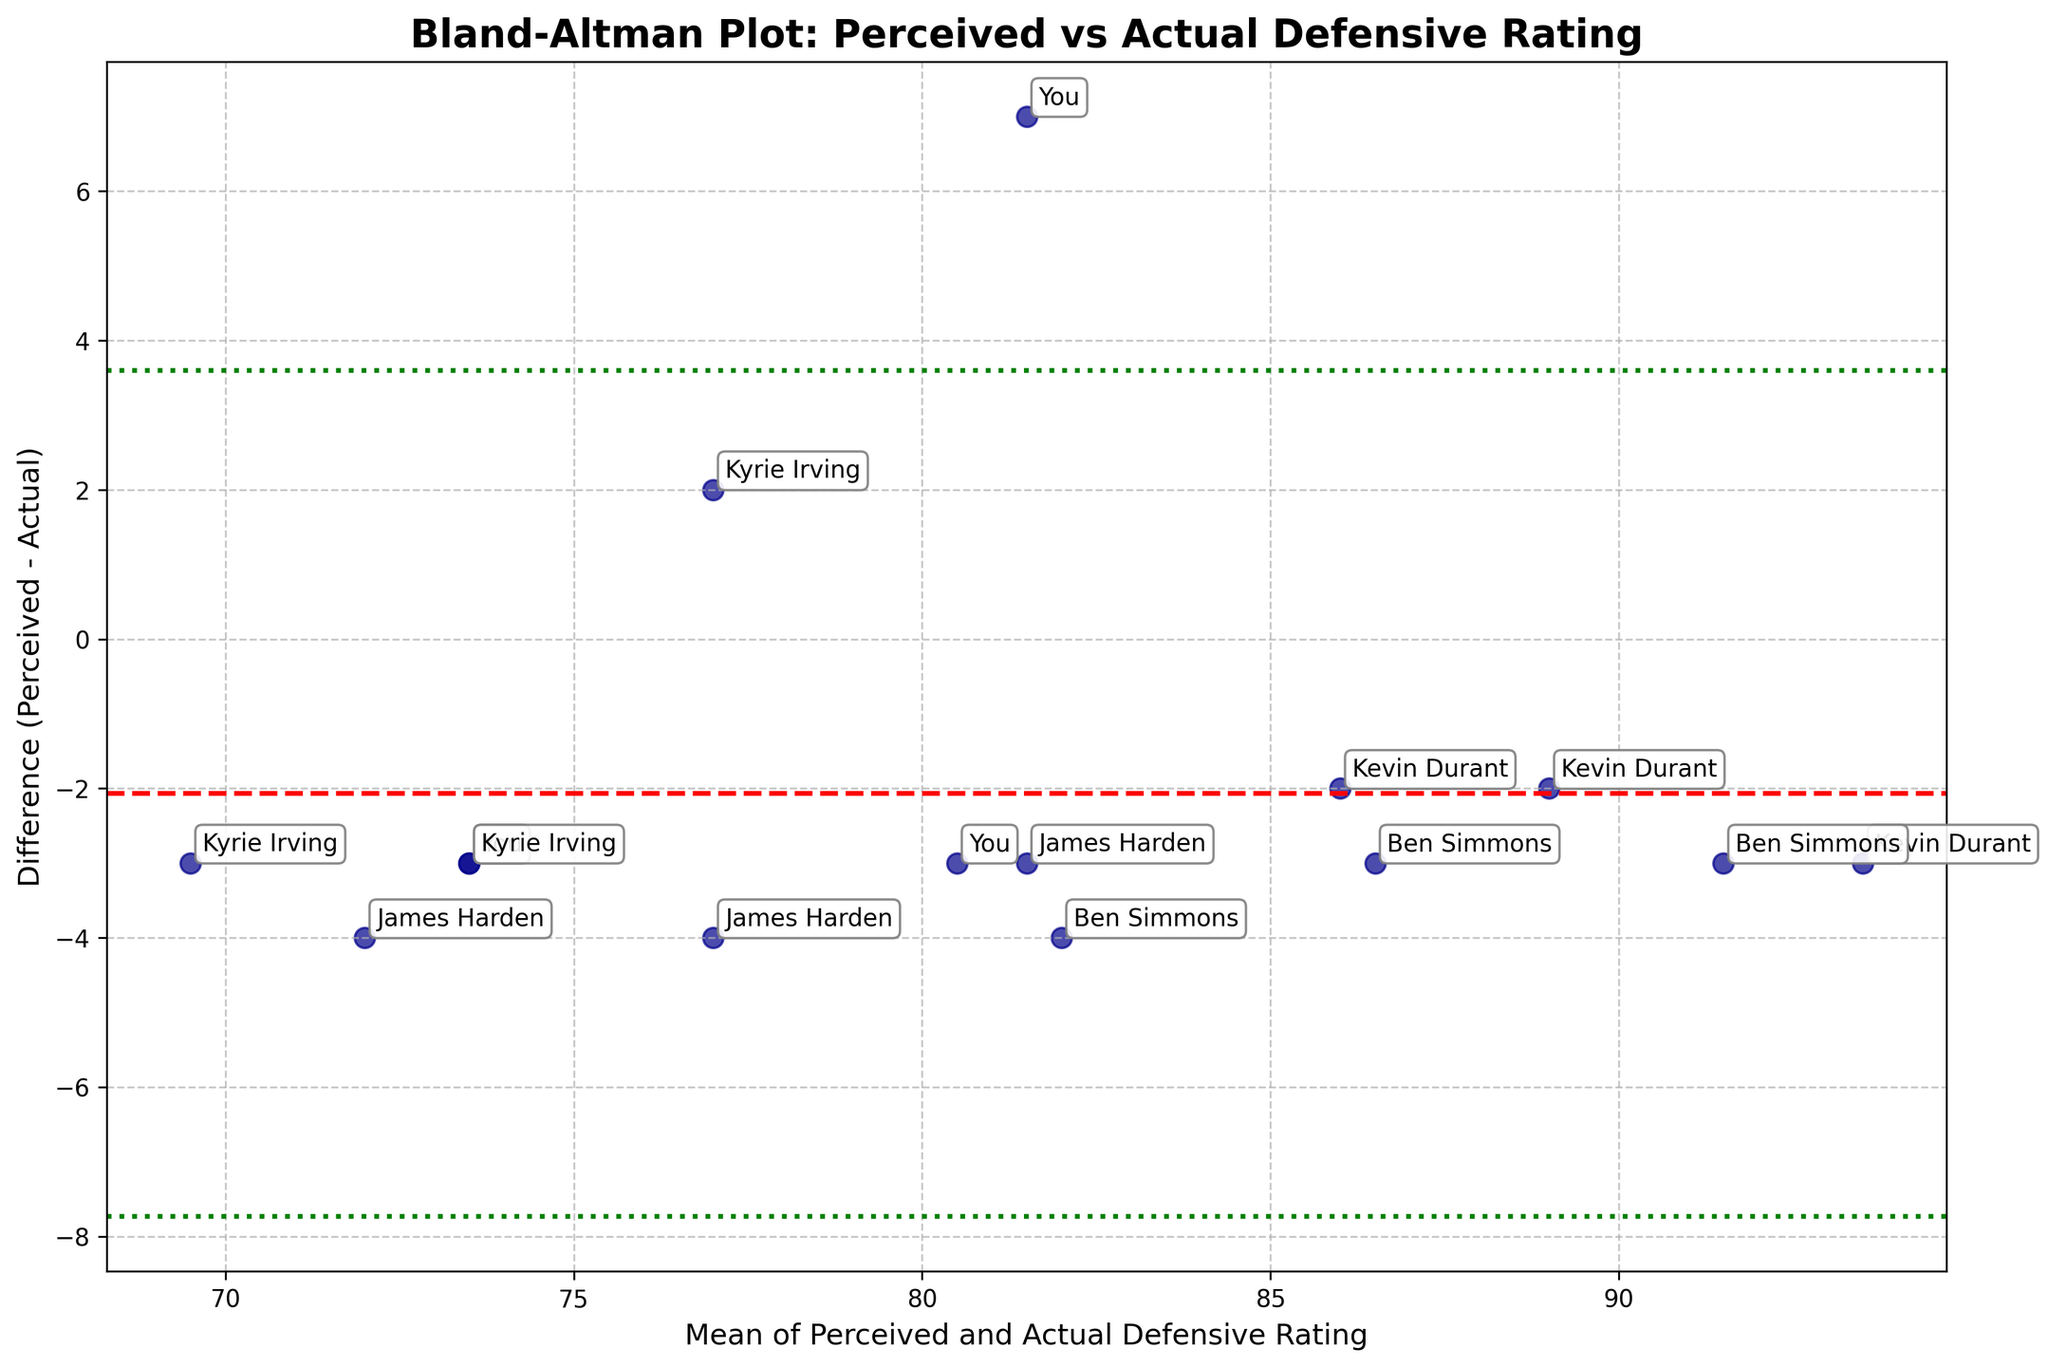How many data points are in the plot? To answer this, count the number of data points (or player-opponent skill level combinations) shown in the plot. There should be one point for each unique combination in the dataset.
Answer: 15 What is the title of the figure? The title of the figure is displayed at the top of the plot. It summarizes the content and purpose of the plot.
Answer: Bland-Altman Plot: Perceived vs Actual Defensive Rating What is the mean difference value indicated by the red dashed line? To find the answer, look at the red dashed horizontal line, which represents the average of the differences between perceived and actual defensive ratings.
Answer: Approximately -1.33 Do more players overestimate or underestimate their defensive performance? To answer this, observe the distribution of points above and below the mean difference line. More points above the line indicate overestimation, while more below would indicate underestimation.
Answer: Overestimate What player has the largest deviation between perceived and actual ratings in the plot? Identify the point furthest from the mean difference line, then refer to the annotation to find the player's name.
Answer: You (Low Opponent Skill) What's the range of the differences (Perceived - Actual) indicated by the green dotted lines? To answer, find the positions of the green dotted lines that indicate the limits (mean difference ± 1.96 standard deviations).
Answer: Approximately from -5.23 to +2.57 Who has the smallest average rating (mean of perceived and actual) against high skilled opponents? Locate the data points for high skilled opponents and compare the mean ratings for each player.
Answer: Kyrie Irving Are there any systematic biases in perceived ratings across different opponent skill levels? Analyze the dispersion and trend of points across different skill levels to determine if there's a consistent overestimation or underestimation trend.
Answer: Yes, a tendency to overestimate Does the plot show that perceived ratings get closer to actual ratings as opponent skill increases? Compare the differences between perceived and actual ratings for low, medium, and high skill levels to observe any trends.
Answer: No, the differences do not seem to systematically decrease with skill level 